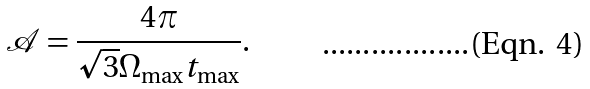<formula> <loc_0><loc_0><loc_500><loc_500>\mathcal { A } = \frac { 4 \pi } { \sqrt { 3 } \Omega _ { \max } t _ { \max } } .</formula> 